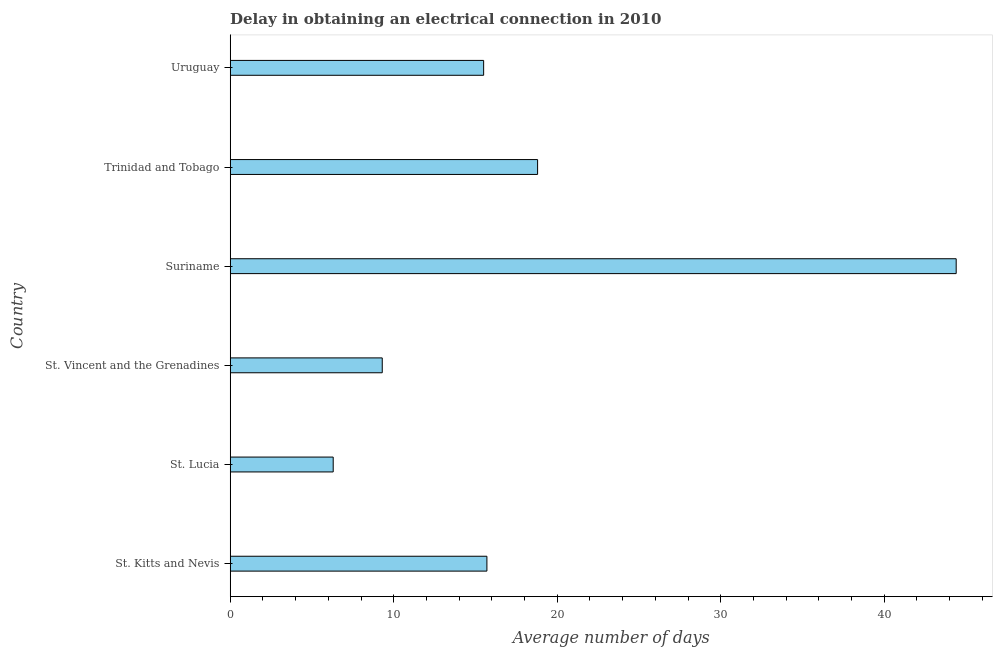Does the graph contain grids?
Your response must be concise. No. What is the title of the graph?
Offer a terse response. Delay in obtaining an electrical connection in 2010. What is the label or title of the X-axis?
Your answer should be very brief. Average number of days. What is the dalay in electrical connection in St. Kitts and Nevis?
Your answer should be compact. 15.7. Across all countries, what is the maximum dalay in electrical connection?
Provide a short and direct response. 44.4. In which country was the dalay in electrical connection maximum?
Give a very brief answer. Suriname. In which country was the dalay in electrical connection minimum?
Offer a terse response. St. Lucia. What is the sum of the dalay in electrical connection?
Your answer should be very brief. 110. What is the difference between the dalay in electrical connection in St. Kitts and Nevis and Trinidad and Tobago?
Keep it short and to the point. -3.1. What is the average dalay in electrical connection per country?
Your answer should be very brief. 18.33. What is the median dalay in electrical connection?
Give a very brief answer. 15.6. What is the ratio of the dalay in electrical connection in St. Lucia to that in St. Vincent and the Grenadines?
Offer a very short reply. 0.68. Is the difference between the dalay in electrical connection in St. Vincent and the Grenadines and Trinidad and Tobago greater than the difference between any two countries?
Your answer should be compact. No. What is the difference between the highest and the second highest dalay in electrical connection?
Keep it short and to the point. 25.6. What is the difference between the highest and the lowest dalay in electrical connection?
Give a very brief answer. 38.1. In how many countries, is the dalay in electrical connection greater than the average dalay in electrical connection taken over all countries?
Offer a terse response. 2. What is the difference between two consecutive major ticks on the X-axis?
Ensure brevity in your answer.  10. Are the values on the major ticks of X-axis written in scientific E-notation?
Provide a short and direct response. No. What is the Average number of days in St. Lucia?
Provide a succinct answer. 6.3. What is the Average number of days of St. Vincent and the Grenadines?
Your response must be concise. 9.3. What is the Average number of days in Suriname?
Your answer should be very brief. 44.4. What is the difference between the Average number of days in St. Kitts and Nevis and St. Vincent and the Grenadines?
Your answer should be very brief. 6.4. What is the difference between the Average number of days in St. Kitts and Nevis and Suriname?
Your answer should be very brief. -28.7. What is the difference between the Average number of days in St. Kitts and Nevis and Uruguay?
Offer a terse response. 0.2. What is the difference between the Average number of days in St. Lucia and St. Vincent and the Grenadines?
Your answer should be very brief. -3. What is the difference between the Average number of days in St. Lucia and Suriname?
Ensure brevity in your answer.  -38.1. What is the difference between the Average number of days in St. Lucia and Uruguay?
Your response must be concise. -9.2. What is the difference between the Average number of days in St. Vincent and the Grenadines and Suriname?
Offer a very short reply. -35.1. What is the difference between the Average number of days in St. Vincent and the Grenadines and Uruguay?
Offer a terse response. -6.2. What is the difference between the Average number of days in Suriname and Trinidad and Tobago?
Offer a terse response. 25.6. What is the difference between the Average number of days in Suriname and Uruguay?
Ensure brevity in your answer.  28.9. What is the ratio of the Average number of days in St. Kitts and Nevis to that in St. Lucia?
Keep it short and to the point. 2.49. What is the ratio of the Average number of days in St. Kitts and Nevis to that in St. Vincent and the Grenadines?
Ensure brevity in your answer.  1.69. What is the ratio of the Average number of days in St. Kitts and Nevis to that in Suriname?
Your answer should be compact. 0.35. What is the ratio of the Average number of days in St. Kitts and Nevis to that in Trinidad and Tobago?
Make the answer very short. 0.83. What is the ratio of the Average number of days in St. Lucia to that in St. Vincent and the Grenadines?
Your answer should be very brief. 0.68. What is the ratio of the Average number of days in St. Lucia to that in Suriname?
Give a very brief answer. 0.14. What is the ratio of the Average number of days in St. Lucia to that in Trinidad and Tobago?
Make the answer very short. 0.34. What is the ratio of the Average number of days in St. Lucia to that in Uruguay?
Offer a terse response. 0.41. What is the ratio of the Average number of days in St. Vincent and the Grenadines to that in Suriname?
Your response must be concise. 0.21. What is the ratio of the Average number of days in St. Vincent and the Grenadines to that in Trinidad and Tobago?
Make the answer very short. 0.49. What is the ratio of the Average number of days in Suriname to that in Trinidad and Tobago?
Offer a terse response. 2.36. What is the ratio of the Average number of days in Suriname to that in Uruguay?
Provide a succinct answer. 2.87. What is the ratio of the Average number of days in Trinidad and Tobago to that in Uruguay?
Offer a very short reply. 1.21. 